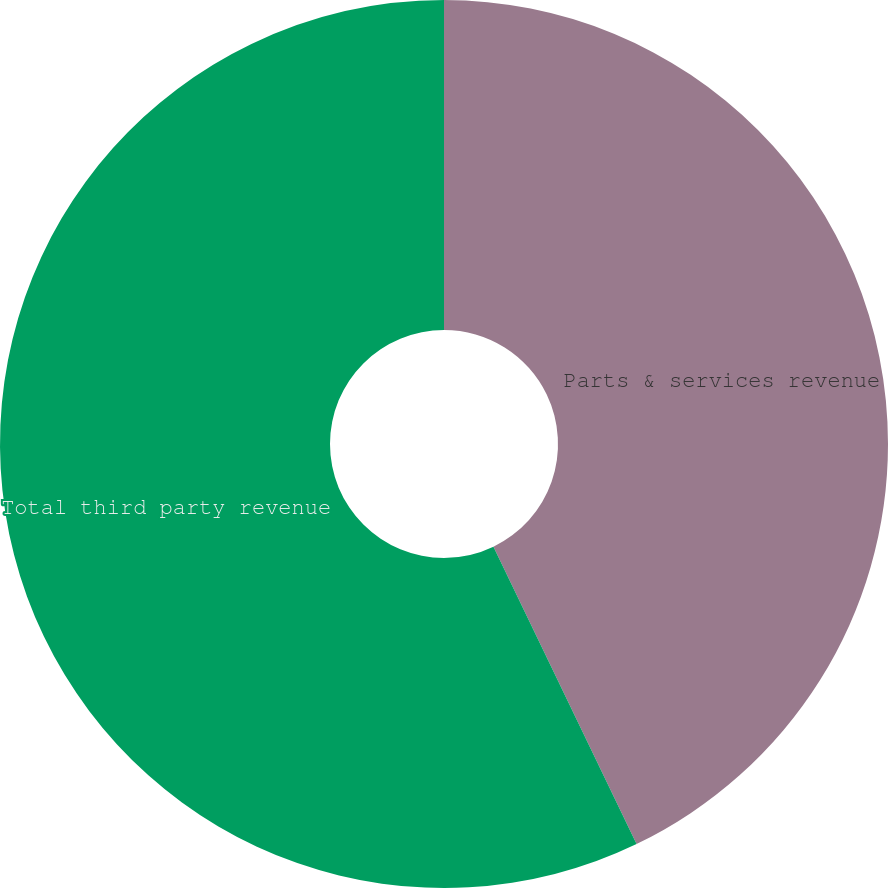Convert chart to OTSL. <chart><loc_0><loc_0><loc_500><loc_500><pie_chart><fcel>Parts & services revenue<fcel>Total third party revenue<nl><fcel>42.86%<fcel>57.14%<nl></chart> 